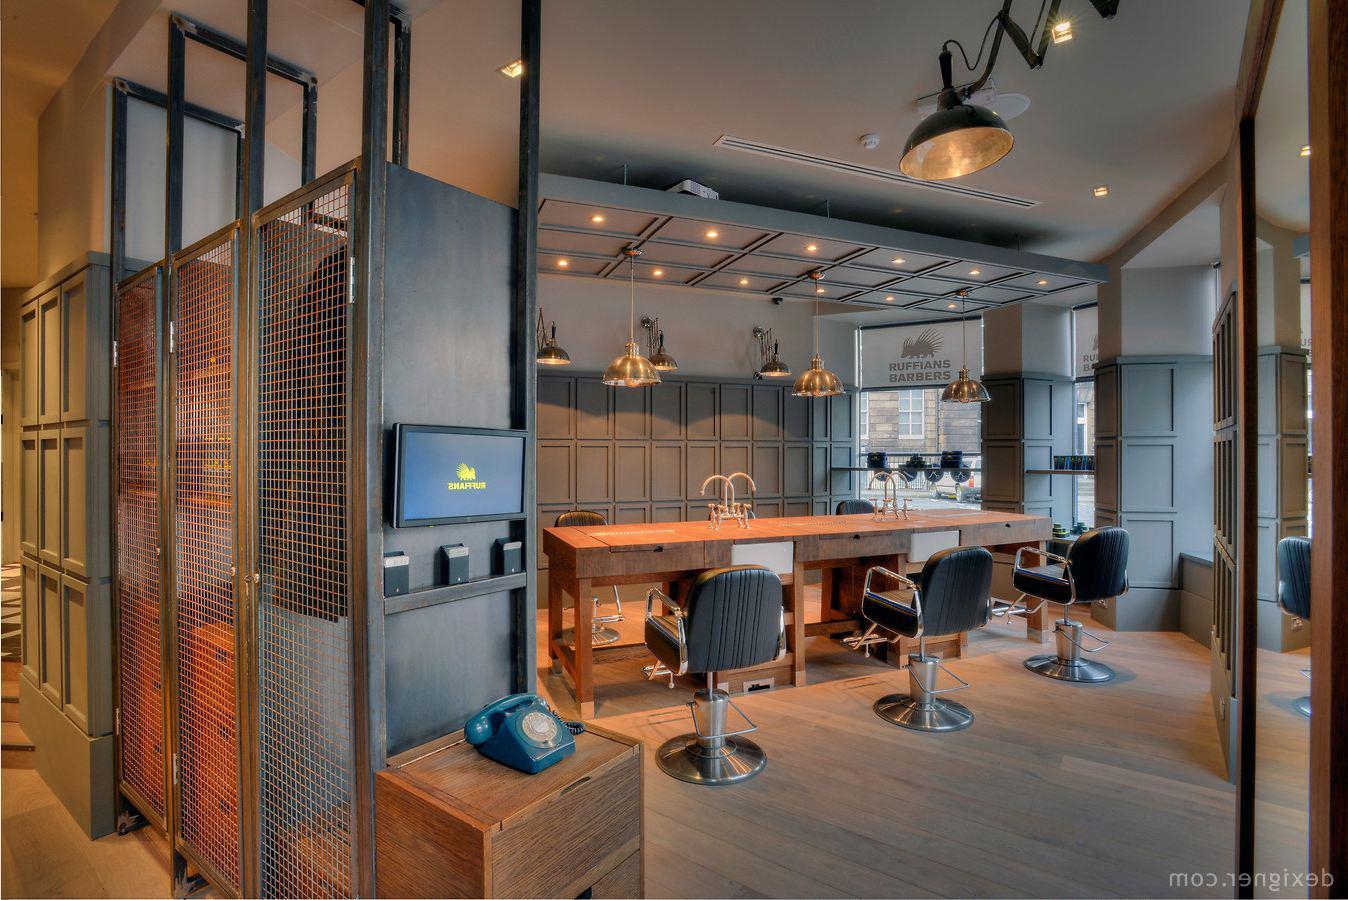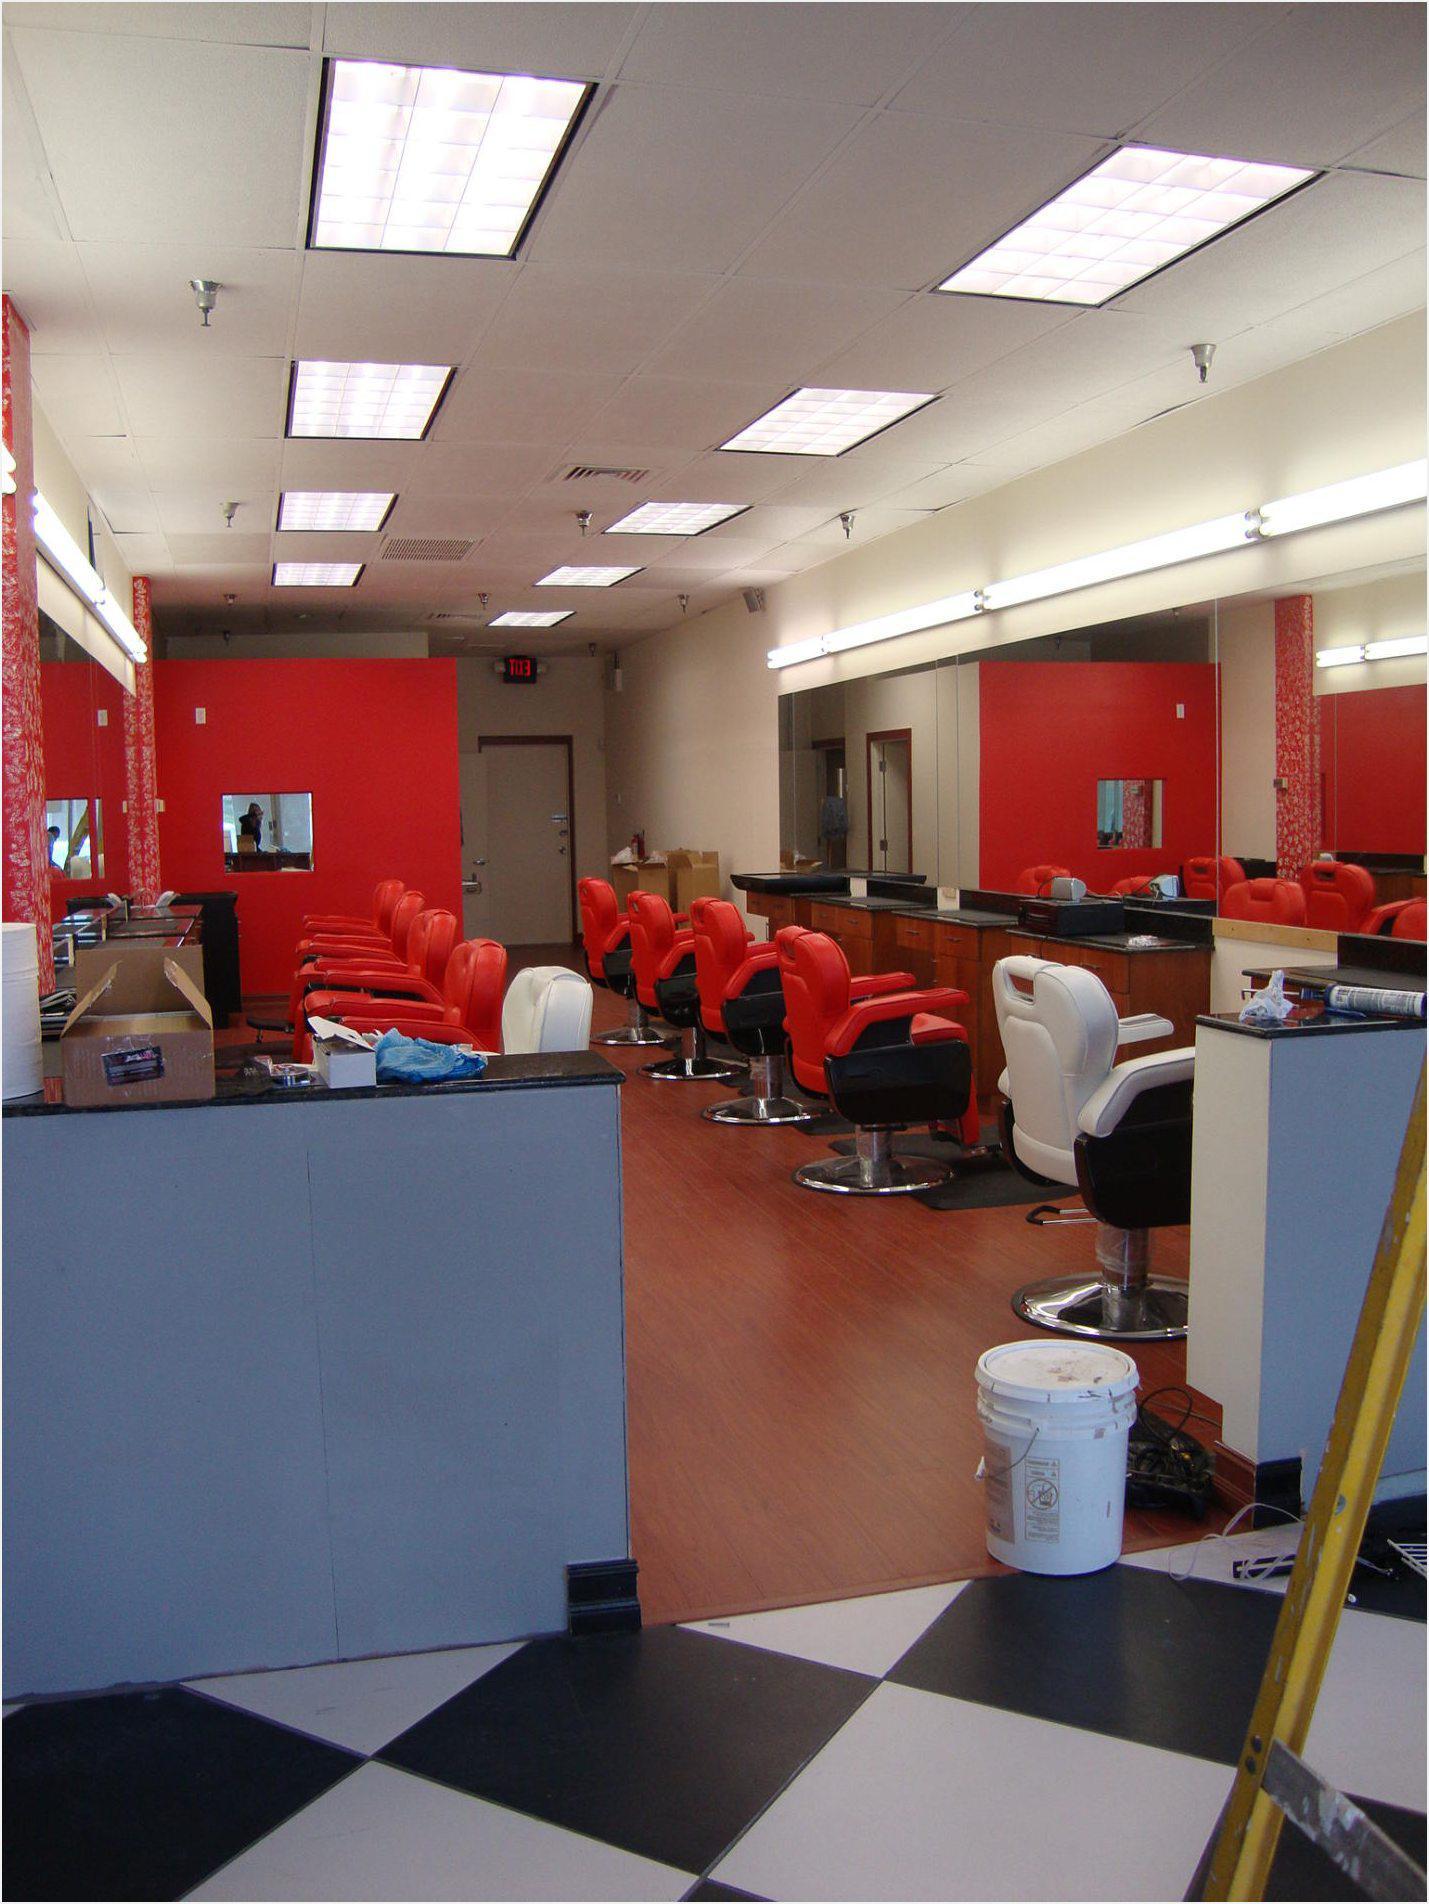The first image is the image on the left, the second image is the image on the right. For the images displayed, is the sentence "In at least one image there are at least two red empty barber chairs." factually correct? Answer yes or no. Yes. The first image is the image on the left, the second image is the image on the right. Assess this claim about the two images: "In the left image, a row of empty black barber chairs face leftward toward a countertop.". Correct or not? Answer yes or no. Yes. 